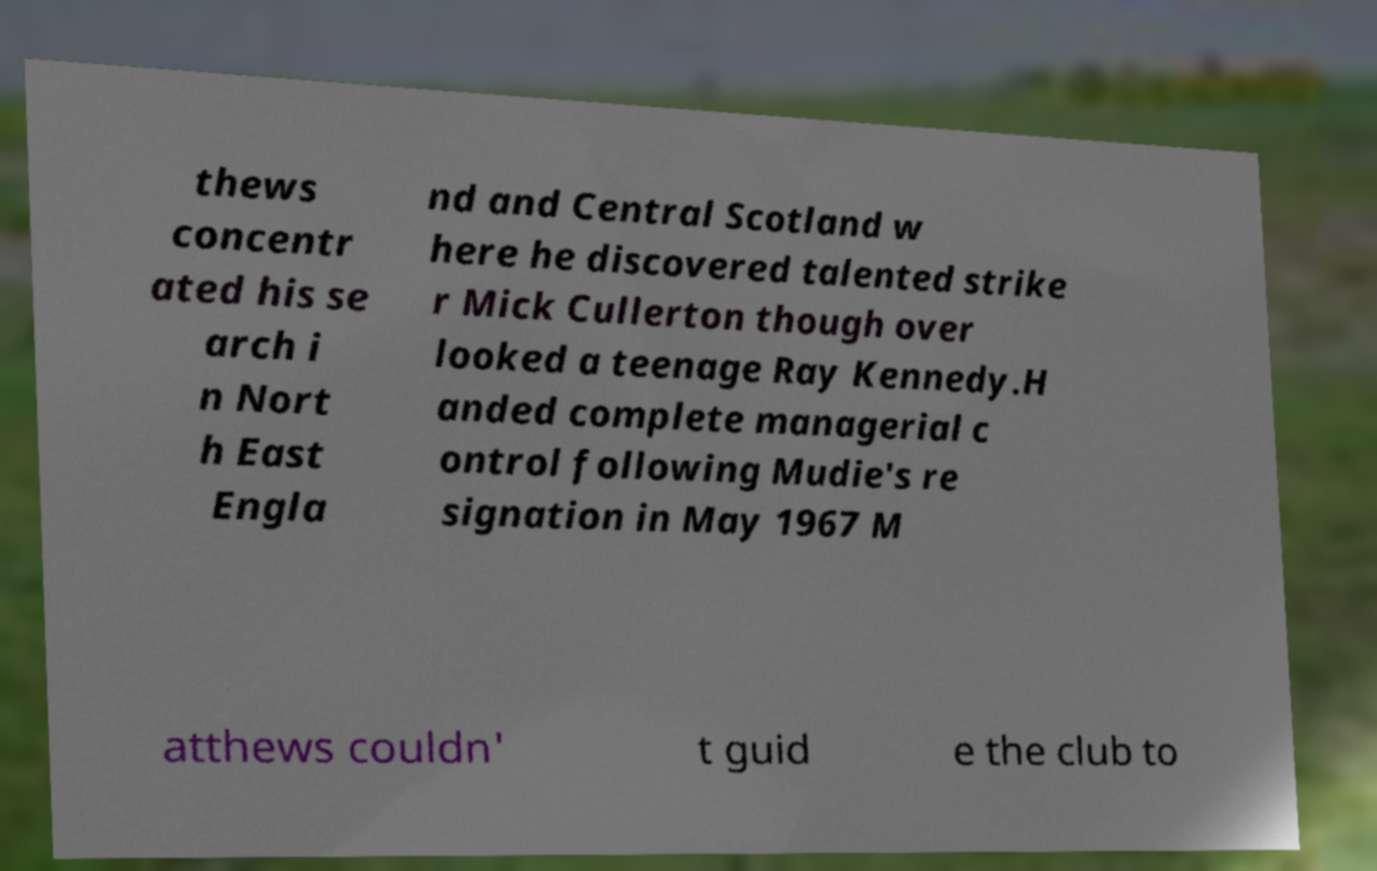What messages or text are displayed in this image? I need them in a readable, typed format. thews concentr ated his se arch i n Nort h East Engla nd and Central Scotland w here he discovered talented strike r Mick Cullerton though over looked a teenage Ray Kennedy.H anded complete managerial c ontrol following Mudie's re signation in May 1967 M atthews couldn' t guid e the club to 